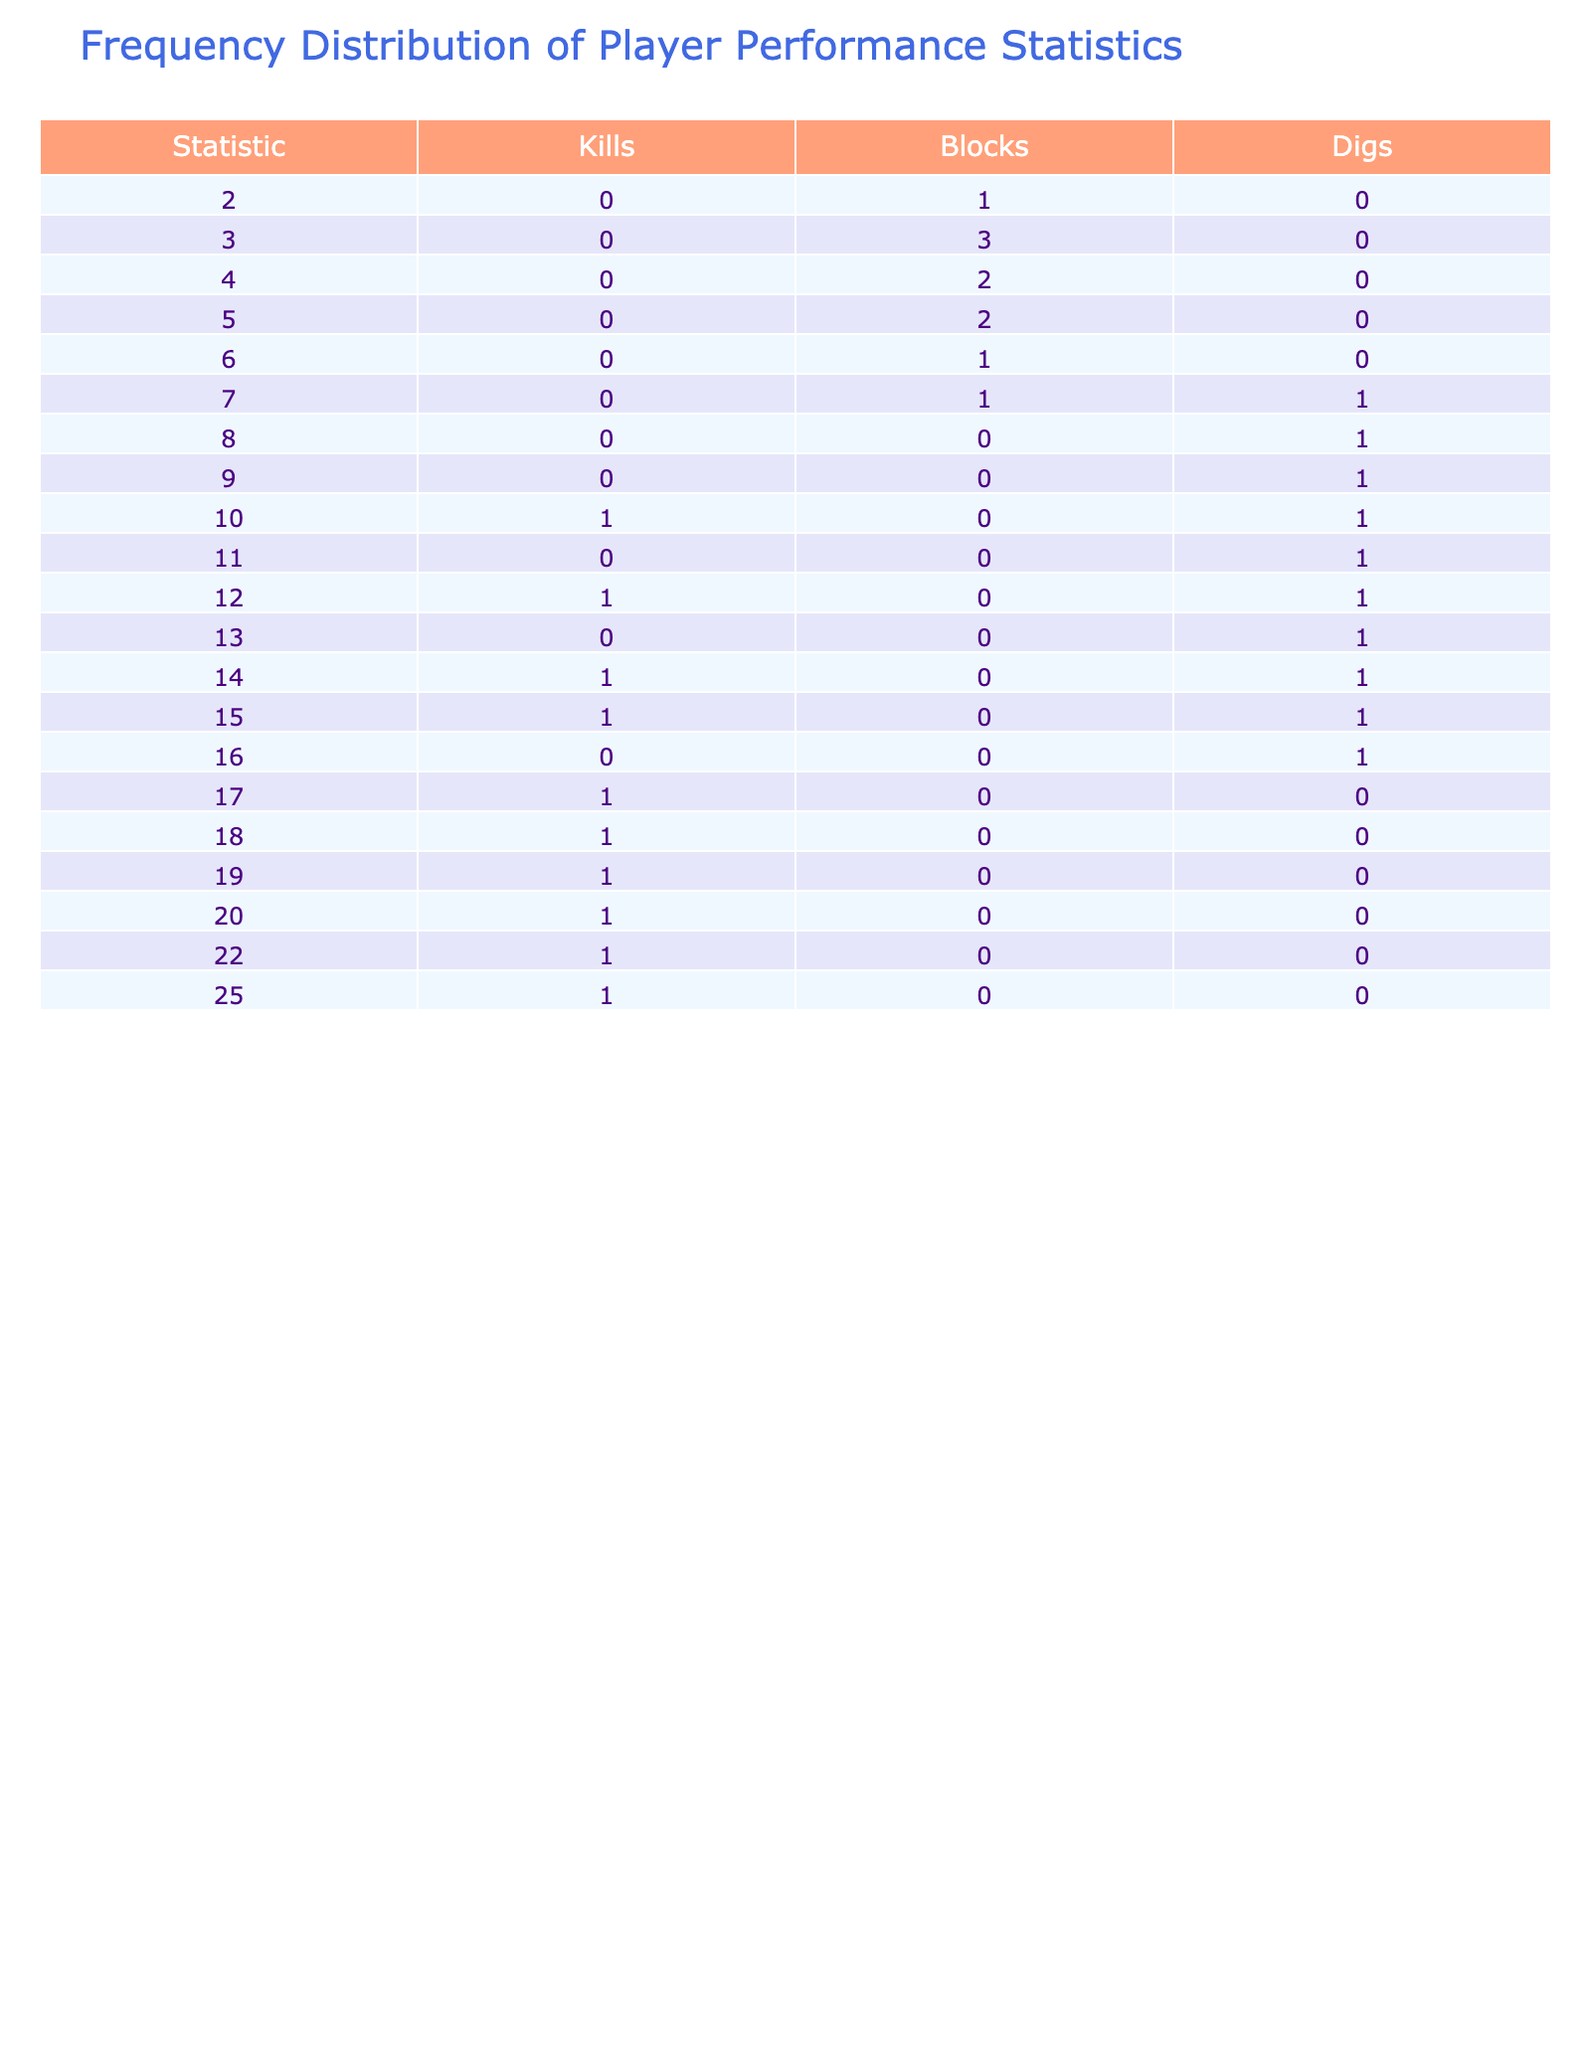What is the maximum number of kills scored by a player? Scanning the 'Kills' column in the table, the highest value is 25, which corresponds to George Miller.
Answer: 25 Who recorded the fewest blocks? Looking at the 'Blocks' column, the minimum value is 2, found in the records of Fiona Garcia.
Answer: 2 Which player had the highest number of digs? Referring to the 'Digs' column, the maximum number of digs is 16, achieved by Ian Wilson.
Answer: 16 What is the average number of kills among all players? To find the average, add the kills: 15 + 20 + 12 + 18 + 22 + 10 + 25 + 14 + 17 + 19 = 182. There are 10 players, so the average is 182 / 10 = 18.2.
Answer: 18.2 Are there any players who scored exactly 18 kills? Examining the 'Kills' column, only Diana Wong reached exactly 18 kills, confirming the answer is 'yes'.
Answer: Yes Which player had the same number of blocks and digs? Checking the 'Blocks' and 'Digs' columns, Alice Johnson has 3 blocks and 12 digs, while Jack Taylor has 5 blocks and 7 digs, none match directly. Therefore, there are no players with equal blocks and digs.
Answer: No How many players recorded more digs than kills? Comparing each player's 'Kills' and 'Digs', we find Chris Lee (12 kills, 15 digs), Fiona Garcia (10 kills, 14 digs), and Ian Wilson (17 kills, 16 digs). Hence, there are 3 players with more digs than kills.
Answer: 3 What is the total number of blocks scored by all players? The total blocks are calculated by summing: 3 + 5 + 4 + 6 + 3 + 2 + 7 + 3 + 4 + 5 = 42.
Answer: 42 How many players achieved 20 or more kills? Reviewing the 'Kills' column, only Ethan Brown (22 kills) and George Miller (25 kills) scored 20 or more kills, which totals 2 players.
Answer: 2 